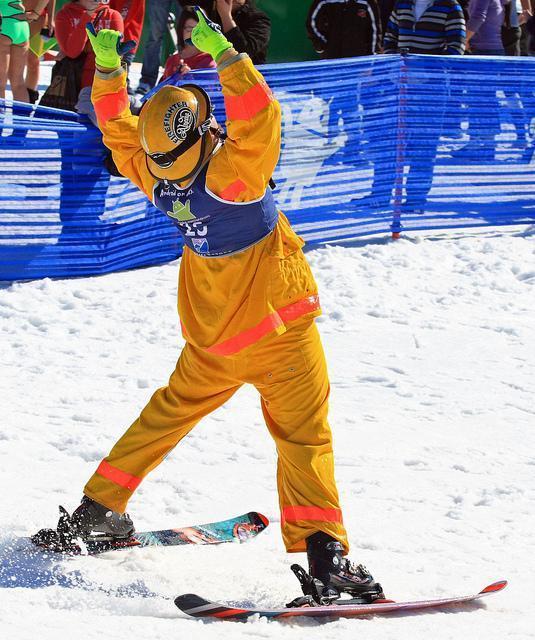How many people are in the photo?
Give a very brief answer. 6. 